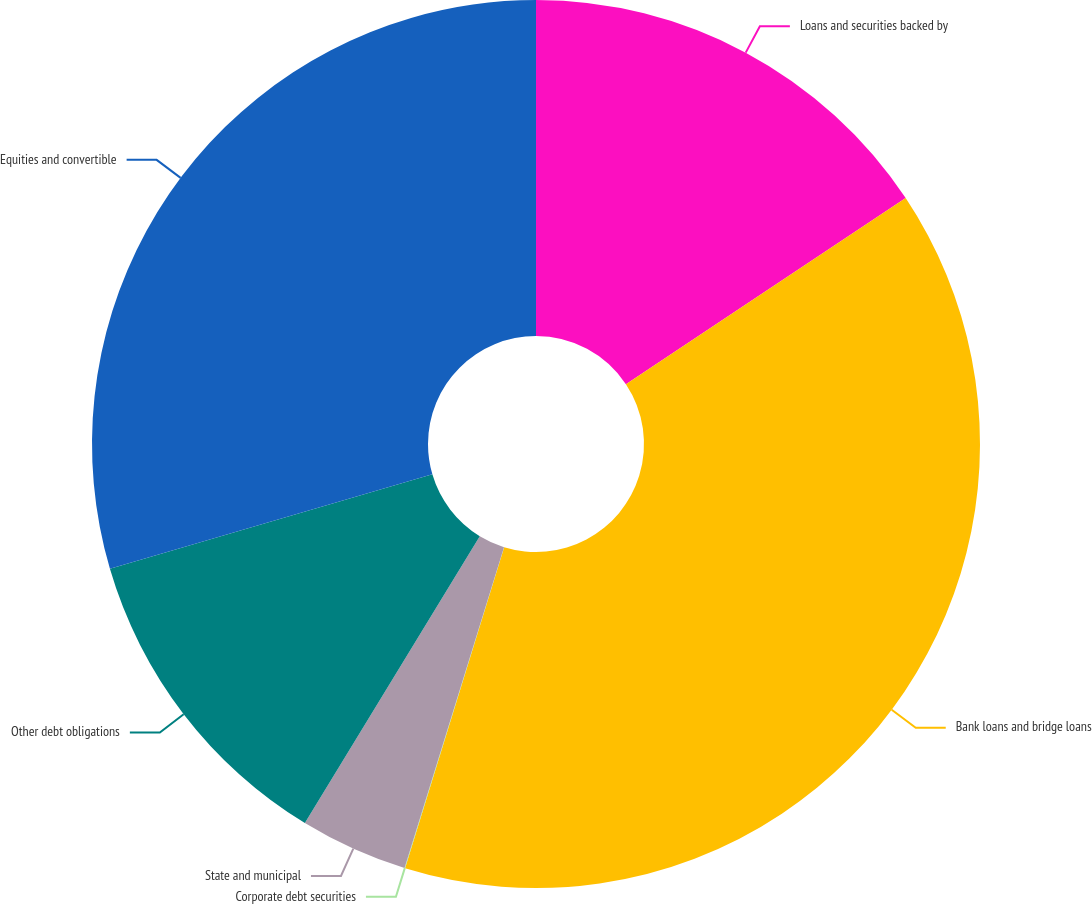<chart> <loc_0><loc_0><loc_500><loc_500><pie_chart><fcel>Loans and securities backed by<fcel>Bank loans and bridge loans<fcel>Corporate debt securities<fcel>State and municipal<fcel>Other debt obligations<fcel>Equities and convertible<nl><fcel>15.66%<fcel>39.11%<fcel>0.02%<fcel>3.93%<fcel>11.75%<fcel>29.54%<nl></chart> 